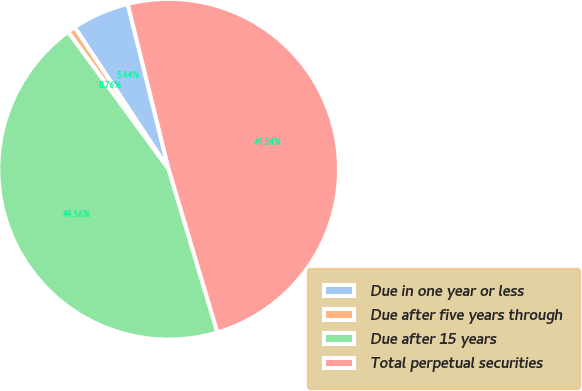Convert chart to OTSL. <chart><loc_0><loc_0><loc_500><loc_500><pie_chart><fcel>Due in one year or less<fcel>Due after five years through<fcel>Due after 15 years<fcel>Total perpetual securities<nl><fcel>5.44%<fcel>0.76%<fcel>44.56%<fcel>49.24%<nl></chart> 